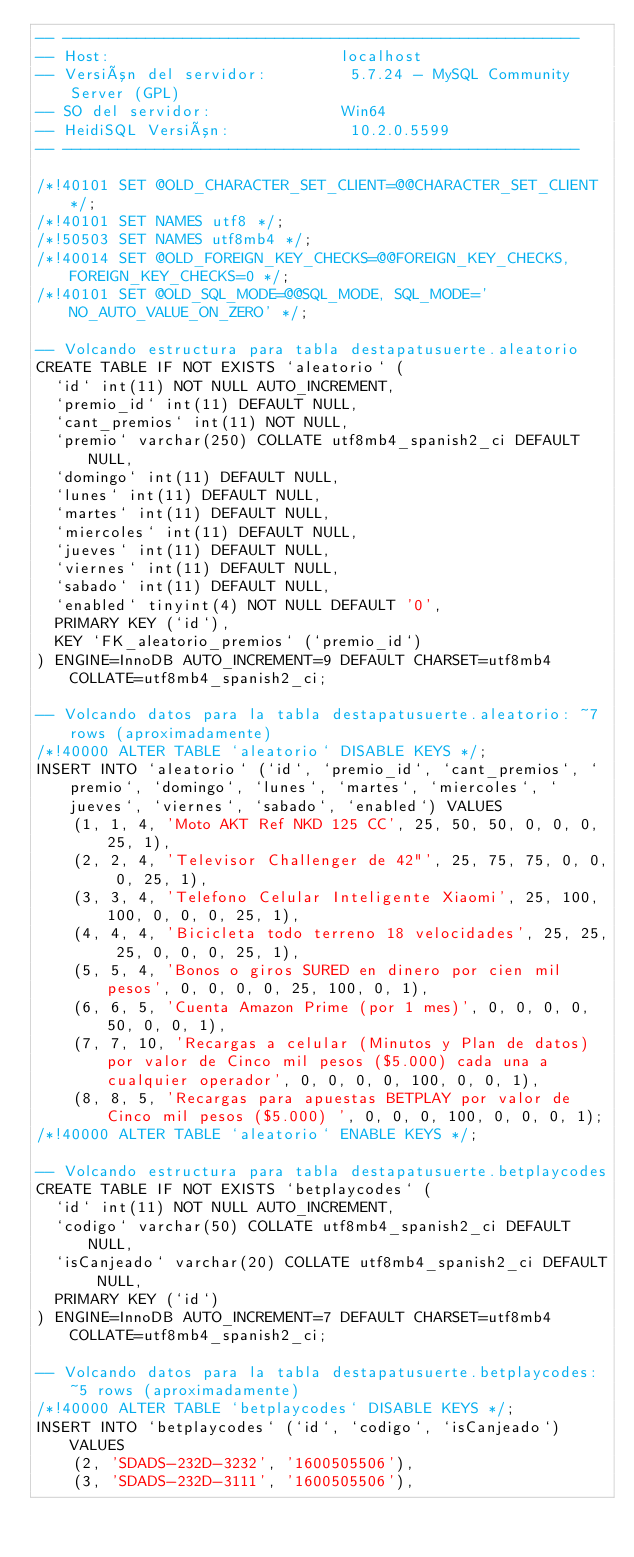<code> <loc_0><loc_0><loc_500><loc_500><_SQL_>-- --------------------------------------------------------
-- Host:                         localhost
-- Versión del servidor:         5.7.24 - MySQL Community Server (GPL)
-- SO del servidor:              Win64
-- HeidiSQL Versión:             10.2.0.5599
-- --------------------------------------------------------

/*!40101 SET @OLD_CHARACTER_SET_CLIENT=@@CHARACTER_SET_CLIENT */;
/*!40101 SET NAMES utf8 */;
/*!50503 SET NAMES utf8mb4 */;
/*!40014 SET @OLD_FOREIGN_KEY_CHECKS=@@FOREIGN_KEY_CHECKS, FOREIGN_KEY_CHECKS=0 */;
/*!40101 SET @OLD_SQL_MODE=@@SQL_MODE, SQL_MODE='NO_AUTO_VALUE_ON_ZERO' */;

-- Volcando estructura para tabla destapatusuerte.aleatorio
CREATE TABLE IF NOT EXISTS `aleatorio` (
  `id` int(11) NOT NULL AUTO_INCREMENT,
  `premio_id` int(11) DEFAULT NULL,
  `cant_premios` int(11) NOT NULL,
  `premio` varchar(250) COLLATE utf8mb4_spanish2_ci DEFAULT NULL,
  `domingo` int(11) DEFAULT NULL,
  `lunes` int(11) DEFAULT NULL,
  `martes` int(11) DEFAULT NULL,
  `miercoles` int(11) DEFAULT NULL,
  `jueves` int(11) DEFAULT NULL,
  `viernes` int(11) DEFAULT NULL,
  `sabado` int(11) DEFAULT NULL,
  `enabled` tinyint(4) NOT NULL DEFAULT '0',
  PRIMARY KEY (`id`),
  KEY `FK_aleatorio_premios` (`premio_id`)
) ENGINE=InnoDB AUTO_INCREMENT=9 DEFAULT CHARSET=utf8mb4 COLLATE=utf8mb4_spanish2_ci;

-- Volcando datos para la tabla destapatusuerte.aleatorio: ~7 rows (aproximadamente)
/*!40000 ALTER TABLE `aleatorio` DISABLE KEYS */;
INSERT INTO `aleatorio` (`id`, `premio_id`, `cant_premios`, `premio`, `domingo`, `lunes`, `martes`, `miercoles`, `jueves`, `viernes`, `sabado`, `enabled`) VALUES
	(1, 1, 4, 'Moto AKT Ref NKD 125 CC', 25, 50, 50, 0, 0, 0, 25, 1),
	(2, 2, 4, 'Televisor Challenger de 42"', 25, 75, 75, 0, 0, 0, 25, 1),
	(3, 3, 4, 'Telefono Celular Inteligente Xiaomi', 25, 100, 100, 0, 0, 0, 25, 1),
	(4, 4, 4, 'Bicicleta todo terreno 18 velocidades', 25, 25, 25, 0, 0, 0, 25, 1),
	(5, 5, 4, 'Bonos o giros SURED en dinero por cien mil pesos', 0, 0, 0, 0, 25, 100, 0, 1),
	(6, 6, 5, 'Cuenta Amazon Prime (por 1 mes)', 0, 0, 0, 0, 50, 0, 0, 1),
	(7, 7, 10, 'Recargas a celular (Minutos y Plan de datos) por valor de Cinco mil pesos ($5.000) cada una a cualquier operador', 0, 0, 0, 0, 100, 0, 0, 1),
	(8, 8, 5, 'Recargas para apuestas BETPLAY por valor de Cinco mil pesos ($5.000) ', 0, 0, 0, 100, 0, 0, 0, 1);
/*!40000 ALTER TABLE `aleatorio` ENABLE KEYS */;

-- Volcando estructura para tabla destapatusuerte.betplaycodes
CREATE TABLE IF NOT EXISTS `betplaycodes` (
  `id` int(11) NOT NULL AUTO_INCREMENT,
  `codigo` varchar(50) COLLATE utf8mb4_spanish2_ci DEFAULT NULL,
  `isCanjeado` varchar(20) COLLATE utf8mb4_spanish2_ci DEFAULT NULL,
  PRIMARY KEY (`id`)
) ENGINE=InnoDB AUTO_INCREMENT=7 DEFAULT CHARSET=utf8mb4 COLLATE=utf8mb4_spanish2_ci;

-- Volcando datos para la tabla destapatusuerte.betplaycodes: ~5 rows (aproximadamente)
/*!40000 ALTER TABLE `betplaycodes` DISABLE KEYS */;
INSERT INTO `betplaycodes` (`id`, `codigo`, `isCanjeado`) VALUES
	(2, 'SDADS-232D-3232', '1600505506'),
	(3, 'SDADS-232D-3111', '1600505506'),</code> 